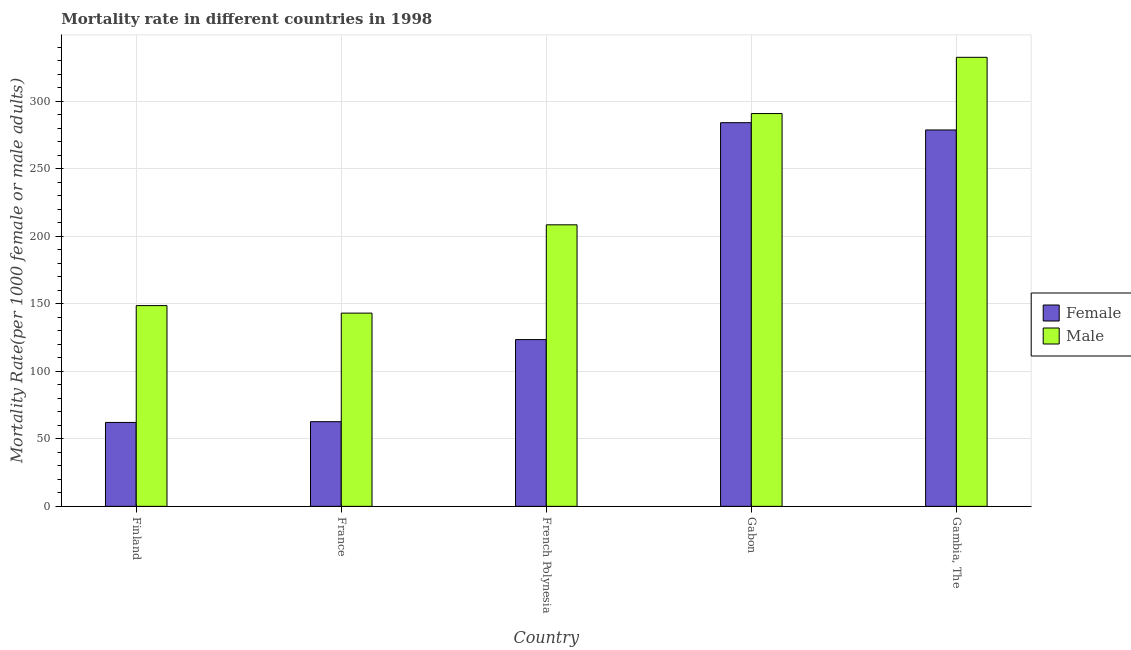Are the number of bars on each tick of the X-axis equal?
Make the answer very short. Yes. How many bars are there on the 2nd tick from the left?
Keep it short and to the point. 2. What is the label of the 3rd group of bars from the left?
Make the answer very short. French Polynesia. In how many cases, is the number of bars for a given country not equal to the number of legend labels?
Keep it short and to the point. 0. What is the male mortality rate in France?
Your answer should be compact. 143.12. Across all countries, what is the maximum male mortality rate?
Provide a succinct answer. 332.59. Across all countries, what is the minimum female mortality rate?
Give a very brief answer. 62.15. In which country was the male mortality rate maximum?
Keep it short and to the point. Gambia, The. In which country was the male mortality rate minimum?
Ensure brevity in your answer.  France. What is the total female mortality rate in the graph?
Provide a succinct answer. 811.36. What is the difference between the male mortality rate in France and that in Gambia, The?
Offer a terse response. -189.47. What is the difference between the male mortality rate in Gabon and the female mortality rate in France?
Keep it short and to the point. 228.22. What is the average male mortality rate per country?
Your response must be concise. 224.77. What is the difference between the female mortality rate and male mortality rate in Finland?
Offer a very short reply. -86.54. What is the ratio of the female mortality rate in Finland to that in French Polynesia?
Your answer should be very brief. 0.5. What is the difference between the highest and the second highest male mortality rate?
Your answer should be very brief. 41.65. What is the difference between the highest and the lowest female mortality rate?
Ensure brevity in your answer.  222.03. In how many countries, is the female mortality rate greater than the average female mortality rate taken over all countries?
Provide a succinct answer. 2. Is the sum of the male mortality rate in France and French Polynesia greater than the maximum female mortality rate across all countries?
Ensure brevity in your answer.  Yes. What does the 2nd bar from the right in French Polynesia represents?
Keep it short and to the point. Female. How many bars are there?
Ensure brevity in your answer.  10. Are all the bars in the graph horizontal?
Offer a very short reply. No. What is the difference between two consecutive major ticks on the Y-axis?
Provide a succinct answer. 50. Are the values on the major ticks of Y-axis written in scientific E-notation?
Offer a terse response. No. Does the graph contain any zero values?
Provide a succinct answer. No. Does the graph contain grids?
Offer a very short reply. Yes. Where does the legend appear in the graph?
Give a very brief answer. Center right. How many legend labels are there?
Provide a succinct answer. 2. What is the title of the graph?
Provide a short and direct response. Mortality rate in different countries in 1998. Does "Public credit registry" appear as one of the legend labels in the graph?
Offer a very short reply. No. What is the label or title of the X-axis?
Give a very brief answer. Country. What is the label or title of the Y-axis?
Your answer should be very brief. Mortality Rate(per 1000 female or male adults). What is the Mortality Rate(per 1000 female or male adults) in Female in Finland?
Offer a terse response. 62.15. What is the Mortality Rate(per 1000 female or male adults) of Male in Finland?
Offer a terse response. 148.69. What is the Mortality Rate(per 1000 female or male adults) of Female in France?
Offer a very short reply. 62.72. What is the Mortality Rate(per 1000 female or male adults) of Male in France?
Offer a very short reply. 143.12. What is the Mortality Rate(per 1000 female or male adults) of Female in French Polynesia?
Your answer should be compact. 123.52. What is the Mortality Rate(per 1000 female or male adults) of Male in French Polynesia?
Offer a terse response. 208.53. What is the Mortality Rate(per 1000 female or male adults) of Female in Gabon?
Ensure brevity in your answer.  284.18. What is the Mortality Rate(per 1000 female or male adults) of Male in Gabon?
Offer a terse response. 290.94. What is the Mortality Rate(per 1000 female or male adults) of Female in Gambia, The?
Your answer should be very brief. 278.79. What is the Mortality Rate(per 1000 female or male adults) in Male in Gambia, The?
Make the answer very short. 332.59. Across all countries, what is the maximum Mortality Rate(per 1000 female or male adults) in Female?
Your answer should be compact. 284.18. Across all countries, what is the maximum Mortality Rate(per 1000 female or male adults) in Male?
Make the answer very short. 332.59. Across all countries, what is the minimum Mortality Rate(per 1000 female or male adults) of Female?
Provide a short and direct response. 62.15. Across all countries, what is the minimum Mortality Rate(per 1000 female or male adults) of Male?
Offer a very short reply. 143.12. What is the total Mortality Rate(per 1000 female or male adults) of Female in the graph?
Your answer should be compact. 811.36. What is the total Mortality Rate(per 1000 female or male adults) in Male in the graph?
Provide a succinct answer. 1123.86. What is the difference between the Mortality Rate(per 1000 female or male adults) in Female in Finland and that in France?
Your answer should be very brief. -0.57. What is the difference between the Mortality Rate(per 1000 female or male adults) in Male in Finland and that in France?
Offer a very short reply. 5.56. What is the difference between the Mortality Rate(per 1000 female or male adults) of Female in Finland and that in French Polynesia?
Offer a very short reply. -61.37. What is the difference between the Mortality Rate(per 1000 female or male adults) in Male in Finland and that in French Polynesia?
Your response must be concise. -59.84. What is the difference between the Mortality Rate(per 1000 female or male adults) of Female in Finland and that in Gabon?
Ensure brevity in your answer.  -222.03. What is the difference between the Mortality Rate(per 1000 female or male adults) in Male in Finland and that in Gabon?
Make the answer very short. -142.25. What is the difference between the Mortality Rate(per 1000 female or male adults) in Female in Finland and that in Gambia, The?
Provide a succinct answer. -216.64. What is the difference between the Mortality Rate(per 1000 female or male adults) in Male in Finland and that in Gambia, The?
Offer a terse response. -183.9. What is the difference between the Mortality Rate(per 1000 female or male adults) of Female in France and that in French Polynesia?
Give a very brief answer. -60.81. What is the difference between the Mortality Rate(per 1000 female or male adults) in Male in France and that in French Polynesia?
Make the answer very short. -65.4. What is the difference between the Mortality Rate(per 1000 female or male adults) in Female in France and that in Gabon?
Provide a succinct answer. -221.47. What is the difference between the Mortality Rate(per 1000 female or male adults) in Male in France and that in Gabon?
Keep it short and to the point. -147.81. What is the difference between the Mortality Rate(per 1000 female or male adults) of Female in France and that in Gambia, The?
Offer a very short reply. -216.07. What is the difference between the Mortality Rate(per 1000 female or male adults) of Male in France and that in Gambia, The?
Your response must be concise. -189.47. What is the difference between the Mortality Rate(per 1000 female or male adults) of Female in French Polynesia and that in Gabon?
Your answer should be compact. -160.66. What is the difference between the Mortality Rate(per 1000 female or male adults) of Male in French Polynesia and that in Gabon?
Ensure brevity in your answer.  -82.41. What is the difference between the Mortality Rate(per 1000 female or male adults) of Female in French Polynesia and that in Gambia, The?
Give a very brief answer. -155.27. What is the difference between the Mortality Rate(per 1000 female or male adults) of Male in French Polynesia and that in Gambia, The?
Offer a very short reply. -124.06. What is the difference between the Mortality Rate(per 1000 female or male adults) of Female in Gabon and that in Gambia, The?
Give a very brief answer. 5.39. What is the difference between the Mortality Rate(per 1000 female or male adults) in Male in Gabon and that in Gambia, The?
Ensure brevity in your answer.  -41.65. What is the difference between the Mortality Rate(per 1000 female or male adults) in Female in Finland and the Mortality Rate(per 1000 female or male adults) in Male in France?
Ensure brevity in your answer.  -80.97. What is the difference between the Mortality Rate(per 1000 female or male adults) of Female in Finland and the Mortality Rate(per 1000 female or male adults) of Male in French Polynesia?
Keep it short and to the point. -146.38. What is the difference between the Mortality Rate(per 1000 female or male adults) in Female in Finland and the Mortality Rate(per 1000 female or male adults) in Male in Gabon?
Provide a succinct answer. -228.79. What is the difference between the Mortality Rate(per 1000 female or male adults) in Female in Finland and the Mortality Rate(per 1000 female or male adults) in Male in Gambia, The?
Offer a very short reply. -270.44. What is the difference between the Mortality Rate(per 1000 female or male adults) of Female in France and the Mortality Rate(per 1000 female or male adults) of Male in French Polynesia?
Your answer should be very brief. -145.81. What is the difference between the Mortality Rate(per 1000 female or male adults) in Female in France and the Mortality Rate(per 1000 female or male adults) in Male in Gabon?
Ensure brevity in your answer.  -228.22. What is the difference between the Mortality Rate(per 1000 female or male adults) of Female in France and the Mortality Rate(per 1000 female or male adults) of Male in Gambia, The?
Provide a succinct answer. -269.87. What is the difference between the Mortality Rate(per 1000 female or male adults) in Female in French Polynesia and the Mortality Rate(per 1000 female or male adults) in Male in Gabon?
Ensure brevity in your answer.  -167.41. What is the difference between the Mortality Rate(per 1000 female or male adults) of Female in French Polynesia and the Mortality Rate(per 1000 female or male adults) of Male in Gambia, The?
Make the answer very short. -209.06. What is the difference between the Mortality Rate(per 1000 female or male adults) in Female in Gabon and the Mortality Rate(per 1000 female or male adults) in Male in Gambia, The?
Your response must be concise. -48.41. What is the average Mortality Rate(per 1000 female or male adults) in Female per country?
Ensure brevity in your answer.  162.27. What is the average Mortality Rate(per 1000 female or male adults) of Male per country?
Keep it short and to the point. 224.77. What is the difference between the Mortality Rate(per 1000 female or male adults) of Female and Mortality Rate(per 1000 female or male adults) of Male in Finland?
Your answer should be compact. -86.54. What is the difference between the Mortality Rate(per 1000 female or male adults) of Female and Mortality Rate(per 1000 female or male adults) of Male in France?
Make the answer very short. -80.41. What is the difference between the Mortality Rate(per 1000 female or male adults) of Female and Mortality Rate(per 1000 female or male adults) of Male in French Polynesia?
Provide a short and direct response. -85. What is the difference between the Mortality Rate(per 1000 female or male adults) in Female and Mortality Rate(per 1000 female or male adults) in Male in Gabon?
Your answer should be compact. -6.75. What is the difference between the Mortality Rate(per 1000 female or male adults) in Female and Mortality Rate(per 1000 female or male adults) in Male in Gambia, The?
Offer a very short reply. -53.8. What is the ratio of the Mortality Rate(per 1000 female or male adults) in Female in Finland to that in France?
Offer a very short reply. 0.99. What is the ratio of the Mortality Rate(per 1000 female or male adults) in Male in Finland to that in France?
Ensure brevity in your answer.  1.04. What is the ratio of the Mortality Rate(per 1000 female or male adults) in Female in Finland to that in French Polynesia?
Give a very brief answer. 0.5. What is the ratio of the Mortality Rate(per 1000 female or male adults) of Male in Finland to that in French Polynesia?
Provide a short and direct response. 0.71. What is the ratio of the Mortality Rate(per 1000 female or male adults) of Female in Finland to that in Gabon?
Give a very brief answer. 0.22. What is the ratio of the Mortality Rate(per 1000 female or male adults) in Male in Finland to that in Gabon?
Your answer should be very brief. 0.51. What is the ratio of the Mortality Rate(per 1000 female or male adults) in Female in Finland to that in Gambia, The?
Keep it short and to the point. 0.22. What is the ratio of the Mortality Rate(per 1000 female or male adults) in Male in Finland to that in Gambia, The?
Give a very brief answer. 0.45. What is the ratio of the Mortality Rate(per 1000 female or male adults) of Female in France to that in French Polynesia?
Ensure brevity in your answer.  0.51. What is the ratio of the Mortality Rate(per 1000 female or male adults) in Male in France to that in French Polynesia?
Provide a short and direct response. 0.69. What is the ratio of the Mortality Rate(per 1000 female or male adults) in Female in France to that in Gabon?
Your response must be concise. 0.22. What is the ratio of the Mortality Rate(per 1000 female or male adults) of Male in France to that in Gabon?
Offer a terse response. 0.49. What is the ratio of the Mortality Rate(per 1000 female or male adults) in Female in France to that in Gambia, The?
Ensure brevity in your answer.  0.23. What is the ratio of the Mortality Rate(per 1000 female or male adults) of Male in France to that in Gambia, The?
Your answer should be very brief. 0.43. What is the ratio of the Mortality Rate(per 1000 female or male adults) of Female in French Polynesia to that in Gabon?
Make the answer very short. 0.43. What is the ratio of the Mortality Rate(per 1000 female or male adults) in Male in French Polynesia to that in Gabon?
Give a very brief answer. 0.72. What is the ratio of the Mortality Rate(per 1000 female or male adults) in Female in French Polynesia to that in Gambia, The?
Provide a succinct answer. 0.44. What is the ratio of the Mortality Rate(per 1000 female or male adults) in Male in French Polynesia to that in Gambia, The?
Offer a terse response. 0.63. What is the ratio of the Mortality Rate(per 1000 female or male adults) of Female in Gabon to that in Gambia, The?
Your response must be concise. 1.02. What is the ratio of the Mortality Rate(per 1000 female or male adults) of Male in Gabon to that in Gambia, The?
Keep it short and to the point. 0.87. What is the difference between the highest and the second highest Mortality Rate(per 1000 female or male adults) of Female?
Ensure brevity in your answer.  5.39. What is the difference between the highest and the second highest Mortality Rate(per 1000 female or male adults) of Male?
Offer a very short reply. 41.65. What is the difference between the highest and the lowest Mortality Rate(per 1000 female or male adults) in Female?
Make the answer very short. 222.03. What is the difference between the highest and the lowest Mortality Rate(per 1000 female or male adults) of Male?
Keep it short and to the point. 189.47. 